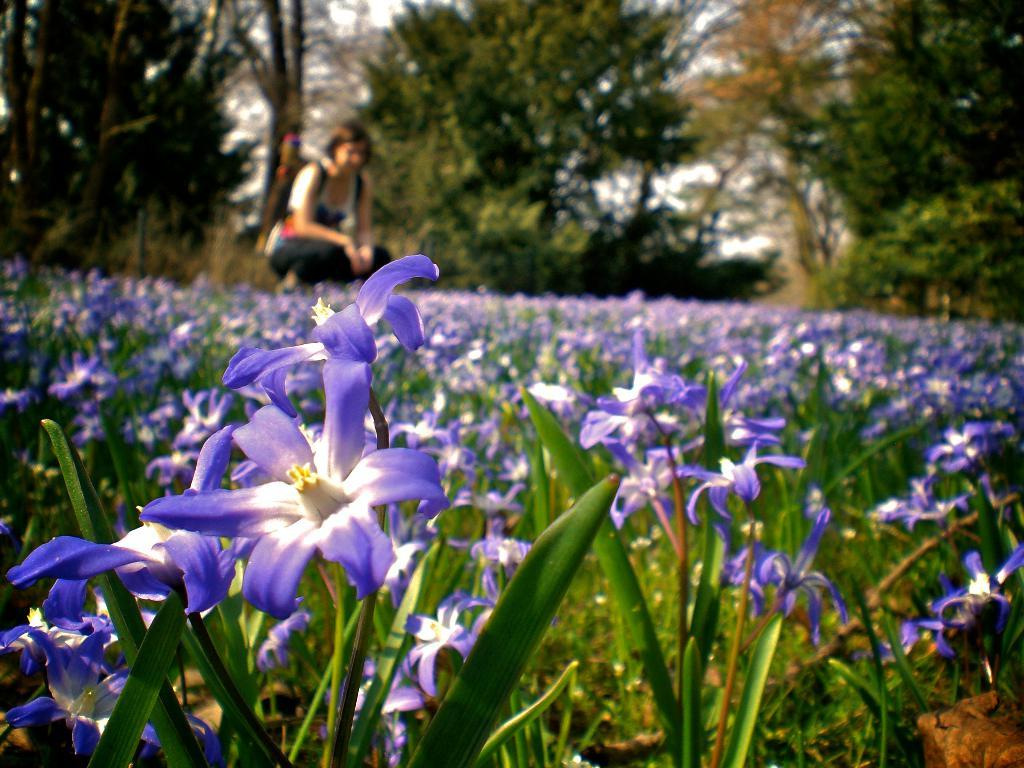What type of plants are in the foreground of the image? There are flowering plants in the foreground of the image. What can be seen in the background of the image? There are trees in the background of the image. Can you describe the woman's position in the image? The woman is on the left side of the image. What type of cork is the woman holding in the image? There is no cork present in the image. What part of the woman's body is made of flesh in the image? The image does not show any specific part of the woman's body being made of flesh; it is a photograph of a woman, and her body is not dissected or shown in a way that highlights any specific part as being made of flesh. 